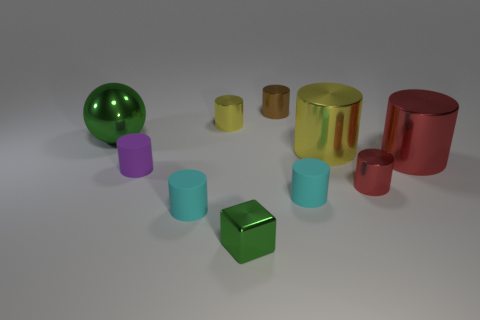What size is the yellow metal thing on the right side of the yellow cylinder that is behind the yellow object that is to the right of the tiny green metallic cube?
Your answer should be compact. Large. There is a metallic cylinder in front of the big red shiny object; what color is it?
Your answer should be very brief. Red. Is the number of tiny red things that are behind the green shiny sphere greater than the number of small purple metallic things?
Your answer should be very brief. No. Is the shape of the tiny brown metal object that is behind the purple object the same as  the small yellow metallic object?
Ensure brevity in your answer.  Yes. How many purple things are rubber cylinders or small things?
Your answer should be compact. 1. Is the number of purple shiny things greater than the number of red objects?
Provide a short and direct response. No. What is the color of the metal block that is the same size as the purple cylinder?
Your response must be concise. Green. What number of cylinders are big metal things or green things?
Make the answer very short. 2. There is a tiny purple object; does it have the same shape as the green thing right of the small purple matte cylinder?
Offer a very short reply. No. What number of red things are the same size as the purple cylinder?
Provide a short and direct response. 1. 